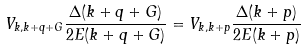<formula> <loc_0><loc_0><loc_500><loc_500>V _ { k , k + q + G } \frac { \Delta ( k + q + G ) } { 2 E ( k + q + G ) } = V _ { k , k + p } \frac { \Delta ( k + p ) } { 2 E ( k + p ) }</formula> 